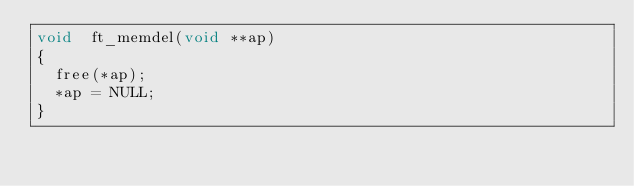Convert code to text. <code><loc_0><loc_0><loc_500><loc_500><_C_>void	ft_memdel(void **ap)
{
	free(*ap);
	*ap = NULL;
}
</code> 